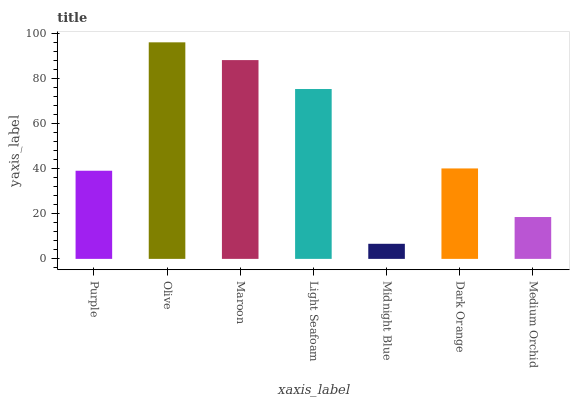Is Midnight Blue the minimum?
Answer yes or no. Yes. Is Olive the maximum?
Answer yes or no. Yes. Is Maroon the minimum?
Answer yes or no. No. Is Maroon the maximum?
Answer yes or no. No. Is Olive greater than Maroon?
Answer yes or no. Yes. Is Maroon less than Olive?
Answer yes or no. Yes. Is Maroon greater than Olive?
Answer yes or no. No. Is Olive less than Maroon?
Answer yes or no. No. Is Dark Orange the high median?
Answer yes or no. Yes. Is Dark Orange the low median?
Answer yes or no. Yes. Is Medium Orchid the high median?
Answer yes or no. No. Is Medium Orchid the low median?
Answer yes or no. No. 